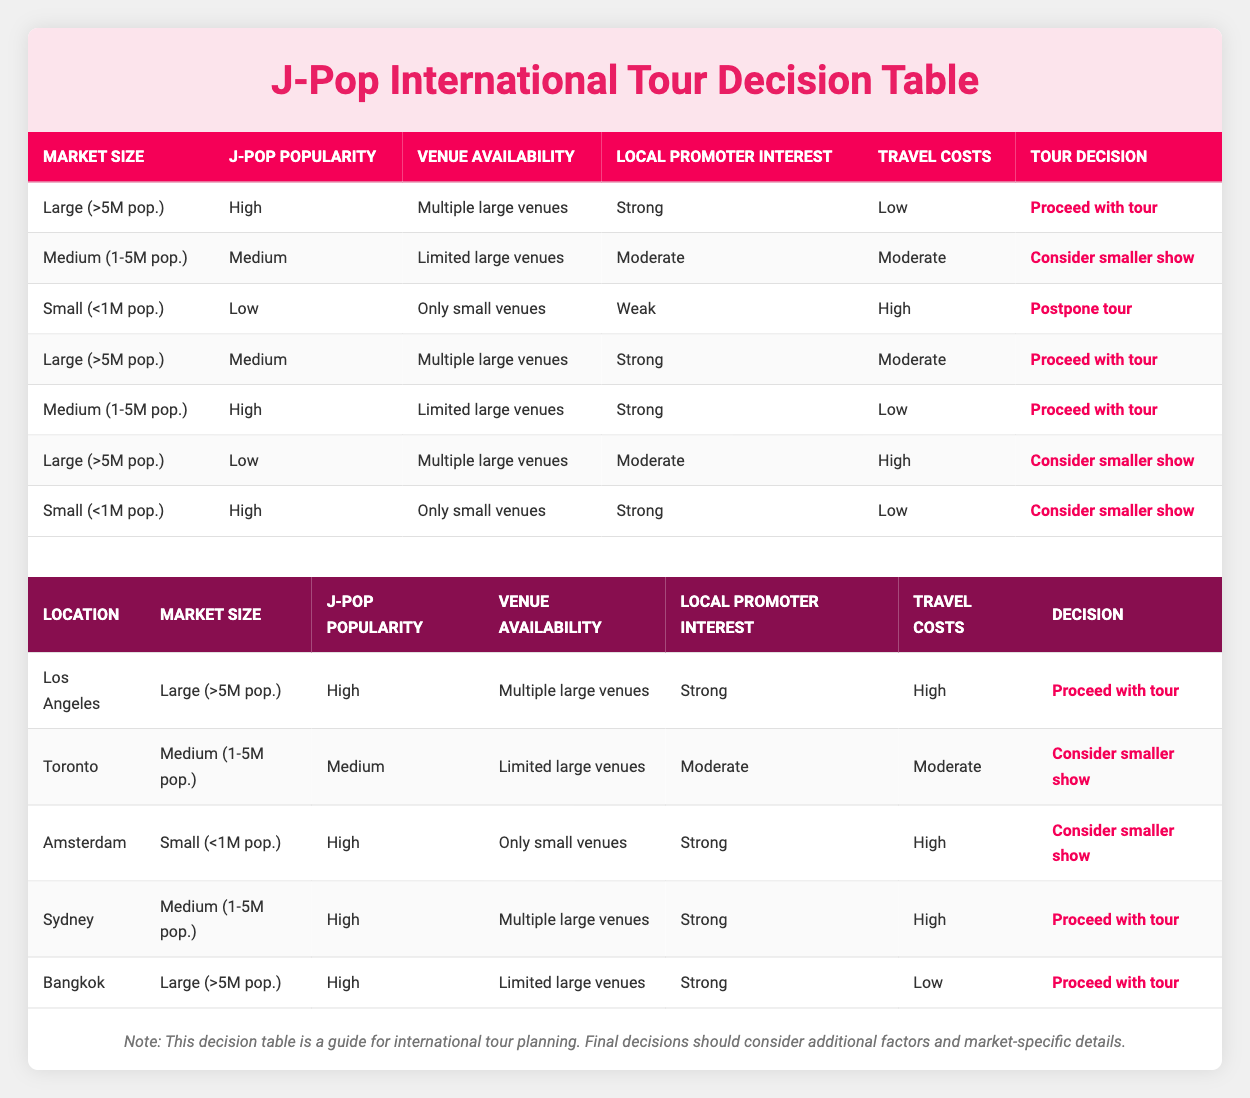What is the decision for a market with a size of Medium and J-Pop popularity rated as High? According to the table, for Medium market size and High J-Pop popularity, it states that the decision is to "Proceed with tour."
Answer: Proceed with tour Which location has the decision to postpone the tour? In the examples, only Amsterdam falls under the category where the conditions lead to "Postpone tour," which is characterized by a Small market, Low J-Pop popularity, Only small venues, Weak local promoter interest, and High travel costs.
Answer: Amsterdam How many locations can proceed with the tour if the market size is Large? By reviewing the table, there are three locations (Los Angeles, Bangkok, and another unspecified large market) where the decision is to "Proceed with tour" with conditions fitting the Large market size.
Answer: Three If a location has Limited large venues and Low J-Pop popularity, what is the likely tour decision? The table indicates that for Limited large venues and Low J-Pop popularity, the decision is to "Consider smaller show," as evidenced by the entry for Toronto.
Answer: Consider smaller show Is there a location where the J-Pop popularity is Low and the decision is to Proceed with the tour? After checking the table, there is no location with Low J-Pop popularity that is associated with the decision to Proceed with tour, as all such cases lead to Consideration of smaller shows or postponements.
Answer: No In total, how many different decisions are specified in this decision table? The table lists three unique decisions: "Proceed with tour," "Consider smaller show," and "Postpone tour," making a total of three different decisions presented.
Answer: Three Which market size has the highest likelihood of proceeding with a tour based on local promoter interest? Based on the table, locations with Large market size combined with Strong local promoter interest consistently lead to the decision to Proceed with tour.
Answer: Large If Travel Costs are Moderate and Local Promoter Interest is Weak, what's the decision? The table does not directly give a location with Moderate travel costs and Weak local promoter interest, but since Weak local promoter is usually not favorable, it implies a negative outcome which would be likely to "Postpone tour."
Answer: Likely Postpone tour 